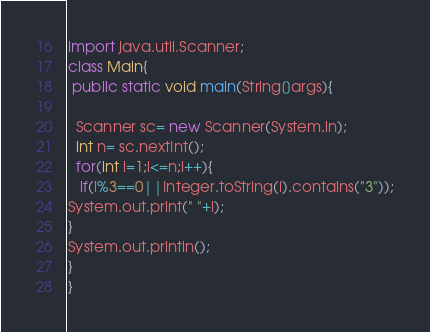<code> <loc_0><loc_0><loc_500><loc_500><_Java_>import java.util.Scanner;
class Main{
 public static void main(String[]args){

  Scanner sc= new Scanner(System.in);
  int n= sc.nextInt();
  for(int i=1;i<=n;i++){
   if(i%3==0||Integer.toString(i).contains("3"));
System.out.print(" "+i);
}
System.out.println();
}
}
</code> 